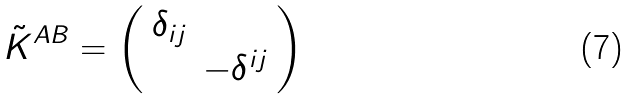Convert formula to latex. <formula><loc_0><loc_0><loc_500><loc_500>\tilde { K } ^ { A B } = \left ( \begin{array} { l l } \delta _ { i j } & \\ & - \delta ^ { i j } \end{array} \right )</formula> 